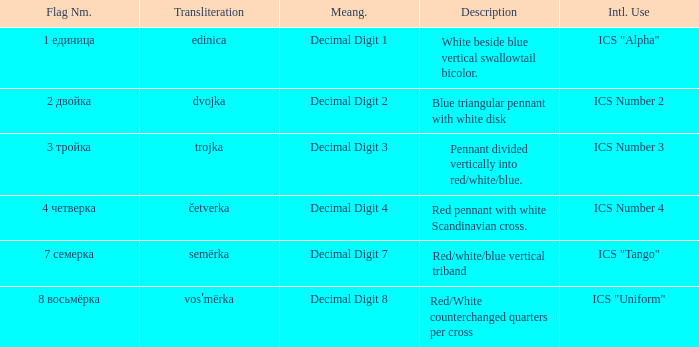What are the meanings of the flag whose name transliterates to dvojka? Decimal Digit 2. 